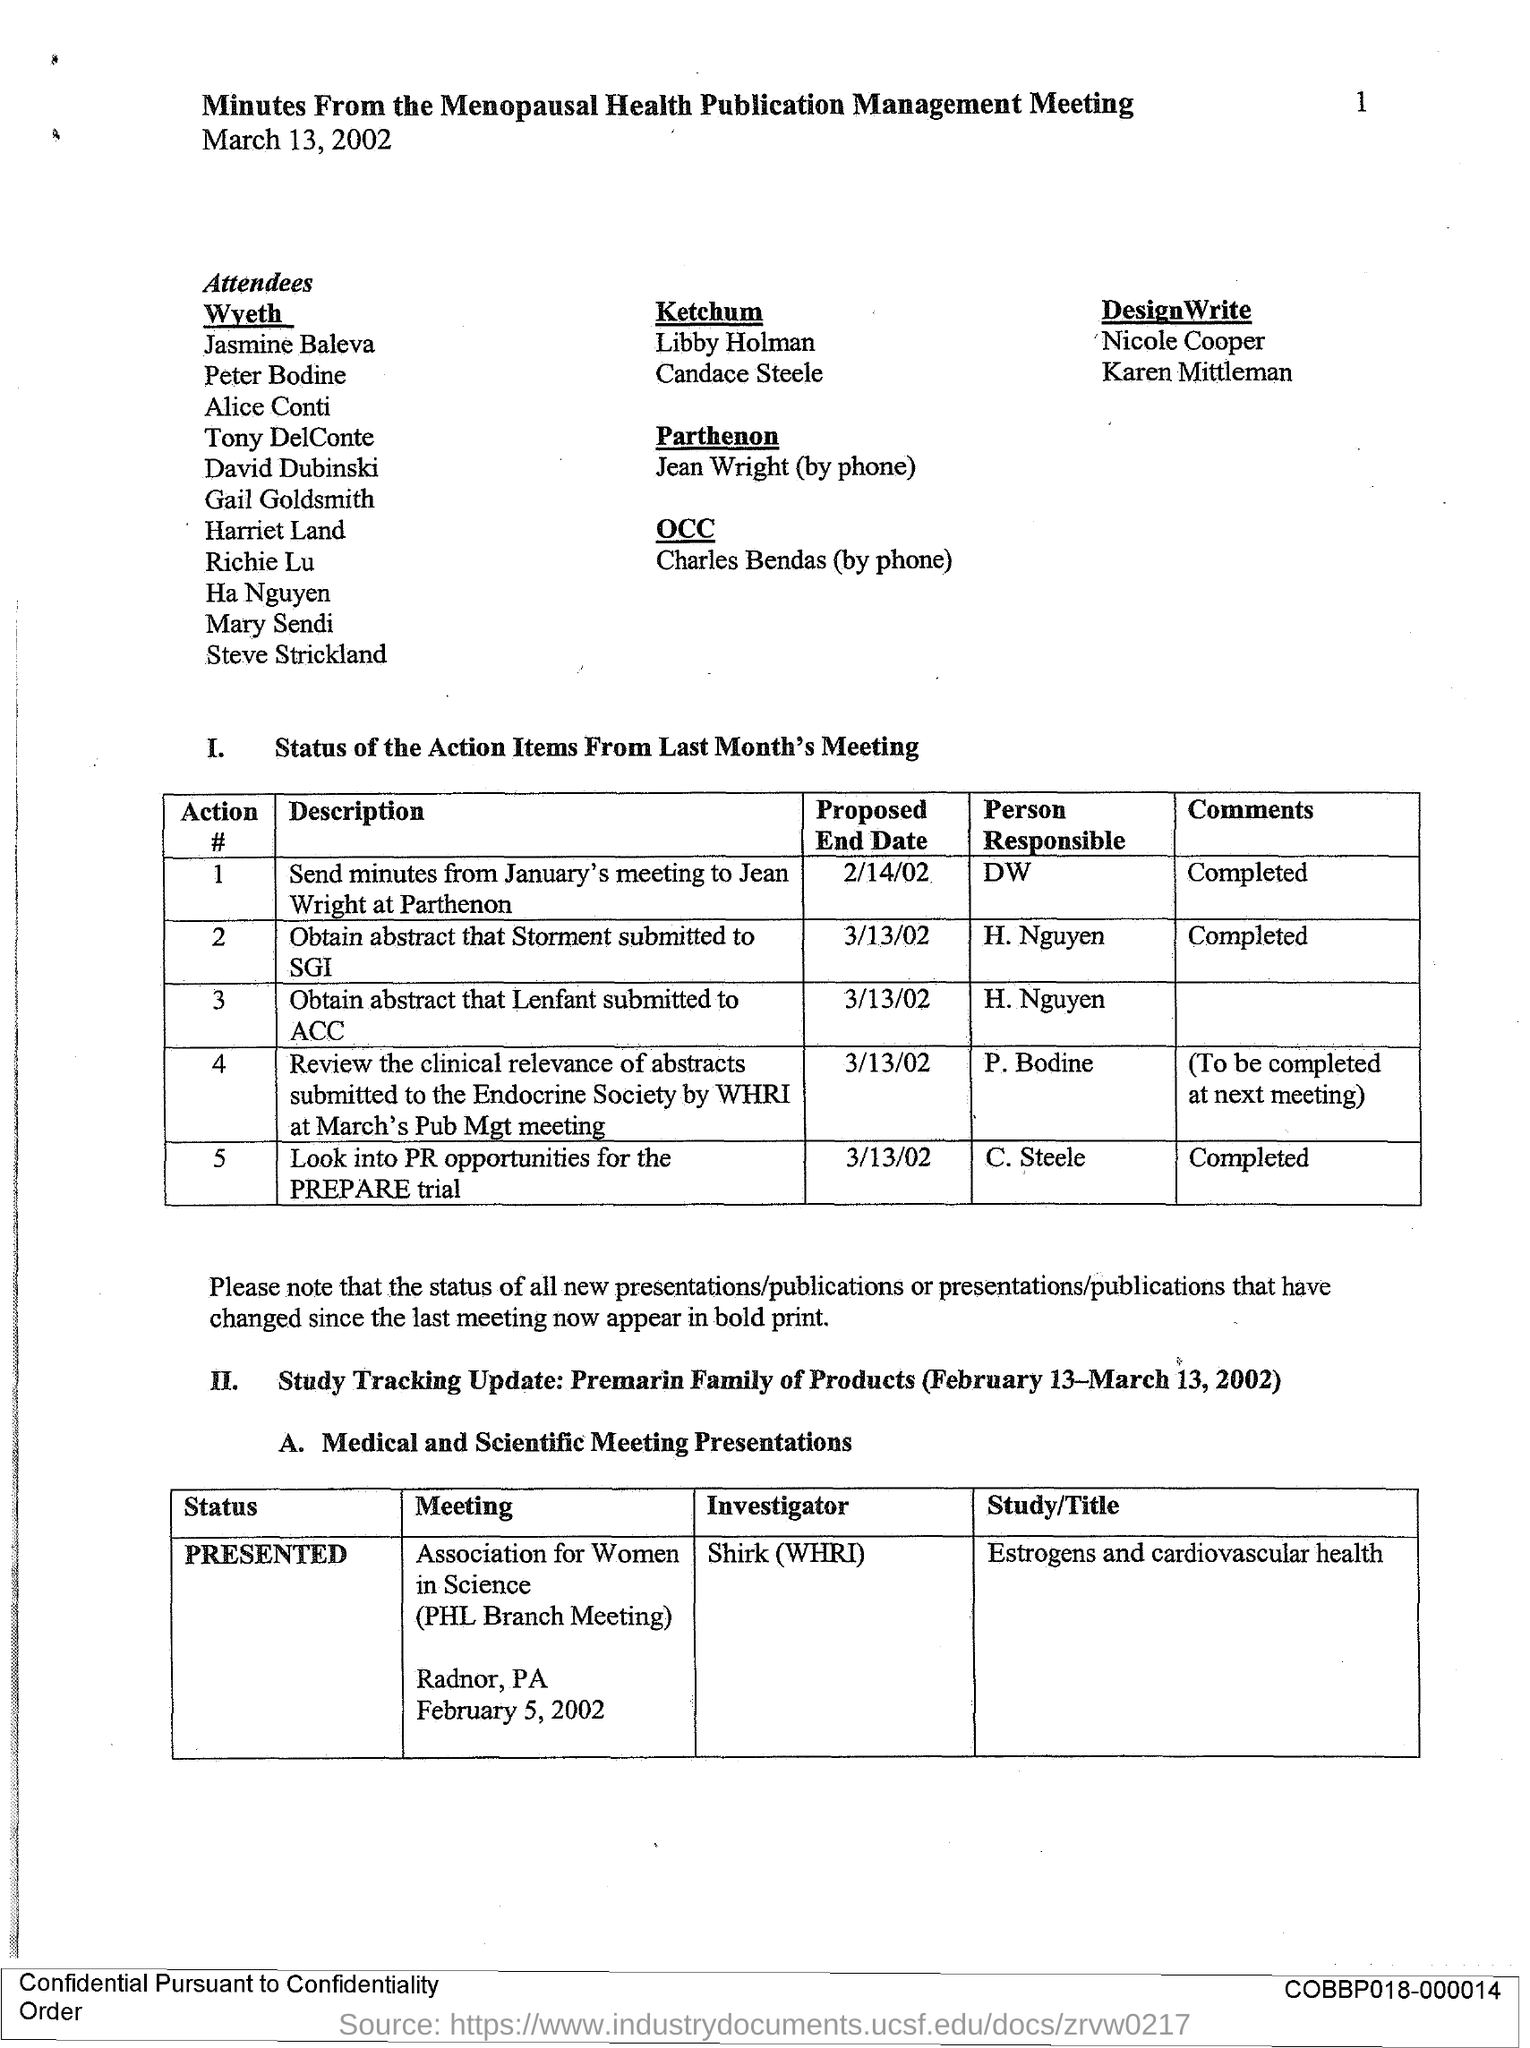Who is the person responsible to obtain abstract that Lenfant submitted to ACC?
Ensure brevity in your answer.  H. NGUYEN. Who is the person responsible to obtain abstract that Storment submitted to SGI?
Ensure brevity in your answer.  H. NGUYEN. What is the proposed end date to send minutes from January's meeting to Jean Wright at Parthenon?
Your answer should be compact. 2/14/02. What is the proposed end date to obtain abstract that Lenfant submitted to ACC?
Give a very brief answer. 3/13/02. What is the proposed end date to obtain the abstract that Storment submitted to SGI?
Offer a very short reply. 3/13/02. 